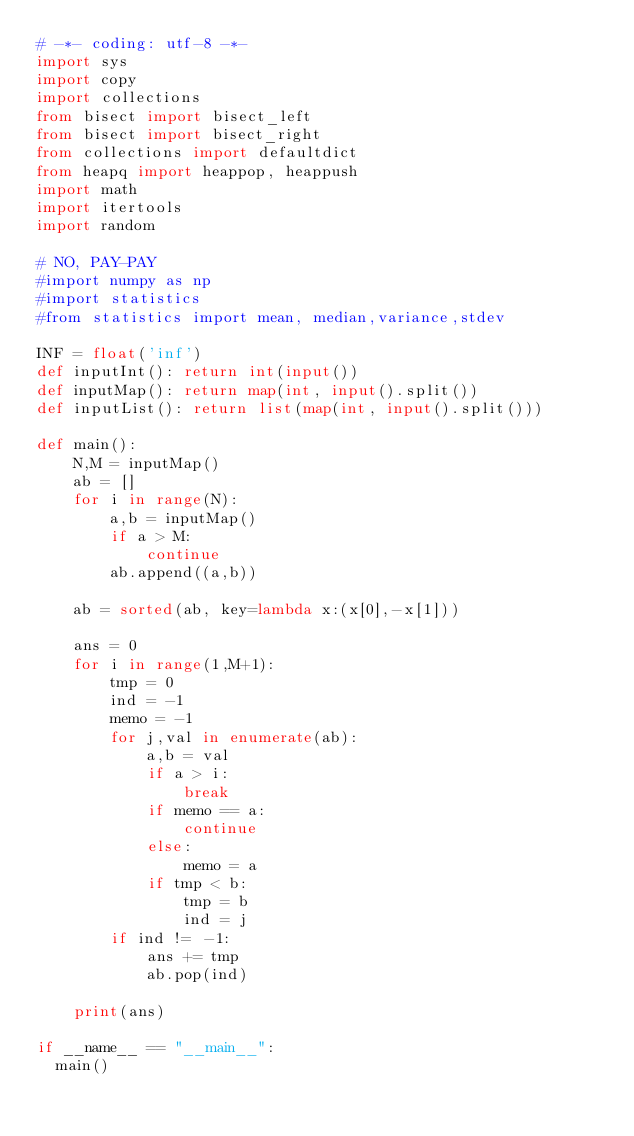Convert code to text. <code><loc_0><loc_0><loc_500><loc_500><_Python_># -*- coding: utf-8 -*-
import sys
import copy
import collections
from bisect import bisect_left
from bisect import bisect_right
from collections import defaultdict
from heapq import heappop, heappush
import math
import itertools
import random
 
# NO, PAY-PAY
#import numpy as np
#import statistics
#from statistics import mean, median,variance,stdev
 
INF = float('inf')
def inputInt(): return int(input())
def inputMap(): return map(int, input().split())
def inputList(): return list(map(int, input().split()))
 
def main():
    N,M = inputMap()
    ab = []
    for i in range(N):
        a,b = inputMap()
        if a > M:
            continue
        ab.append((a,b))
        
    ab = sorted(ab, key=lambda x:(x[0],-x[1]))
    
    ans = 0
    for i in range(1,M+1):
        tmp = 0
        ind = -1
        memo = -1
        for j,val in enumerate(ab):
            a,b = val
            if a > i:
                break
            if memo == a:
                continue
            else:
                memo = a
            if tmp < b:
                tmp = b
                ind = j
        if ind != -1:
            ans += tmp
            ab.pop(ind)
    
    print(ans)
    
if __name__ == "__main__":
	main()
</code> 